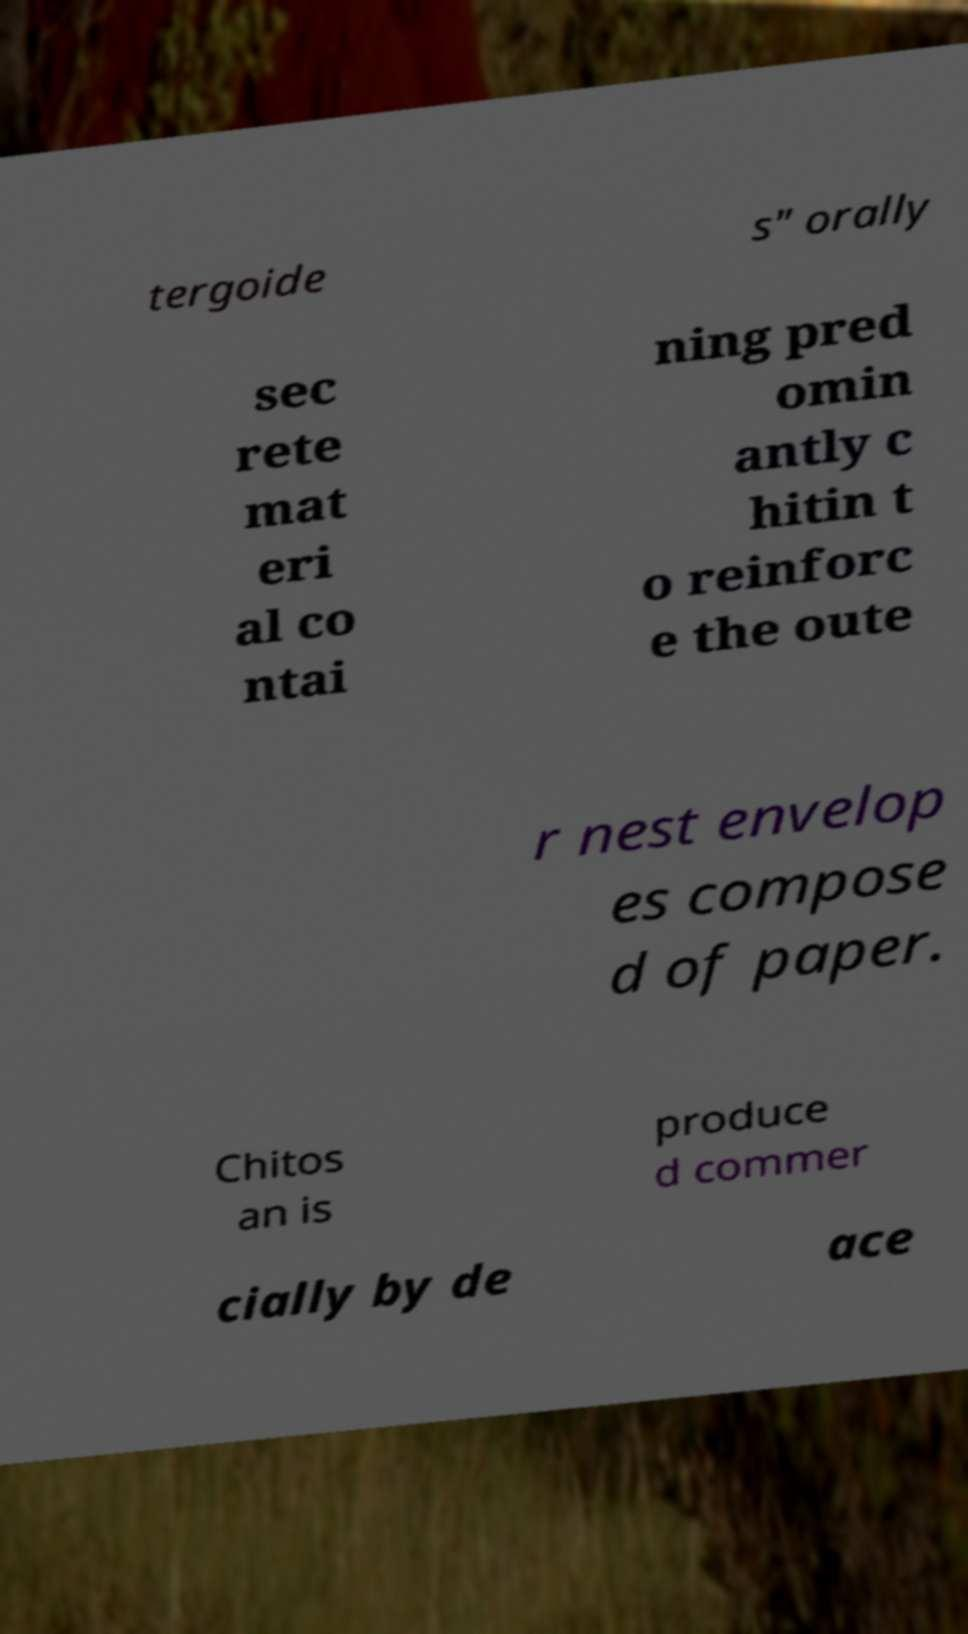There's text embedded in this image that I need extracted. Can you transcribe it verbatim? tergoide s" orally sec rete mat eri al co ntai ning pred omin antly c hitin t o reinforc e the oute r nest envelop es compose d of paper. Chitos an is produce d commer cially by de ace 